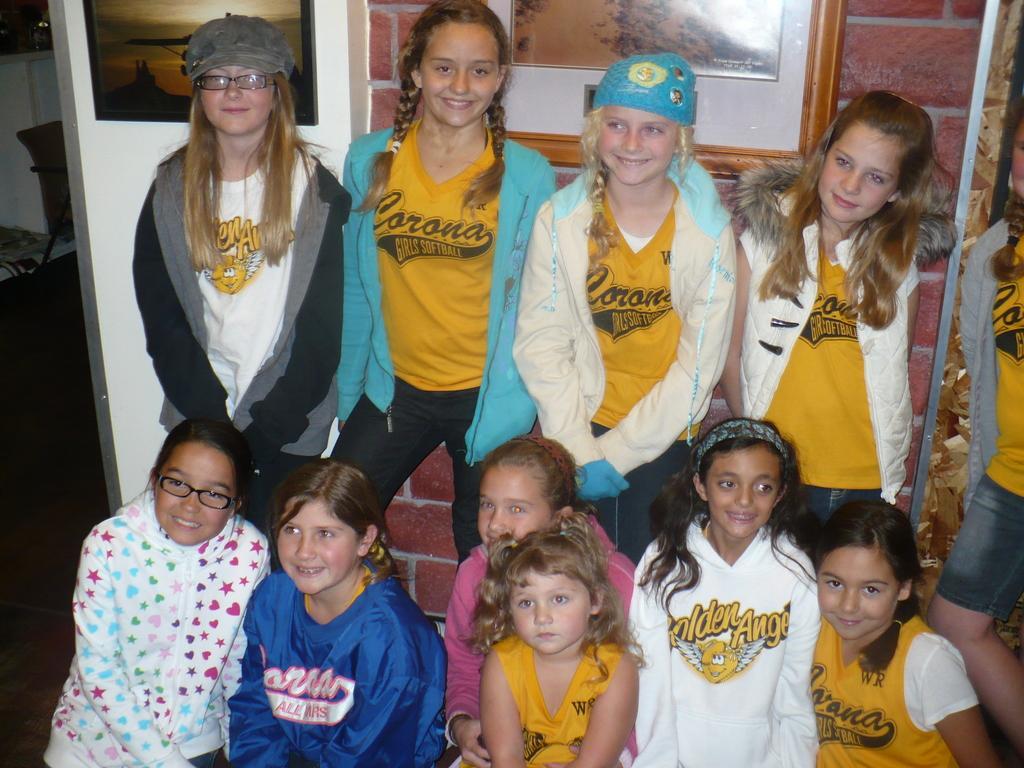Could you give a brief overview of what you see in this image? In this image we can see few children sitting and few of them are standing. In the background of the image there is a wall with photo frames. To the left side of the image there is a chair. 